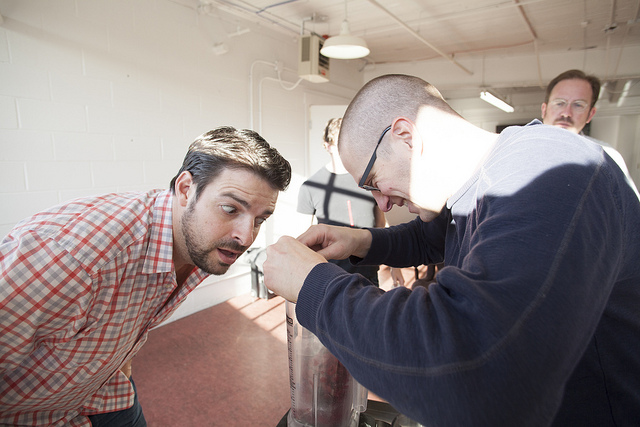<image>What system are they playing this game on? It is ambiguous what system they are playing this game on. It could be a phone, xbox, wii, or other. What system are they playing this game on? It is unclear what system they are playing the game on. It can be 'blender', 'phone', 'xbox', 'wii', 'vitamix', or there might be no system at all. 